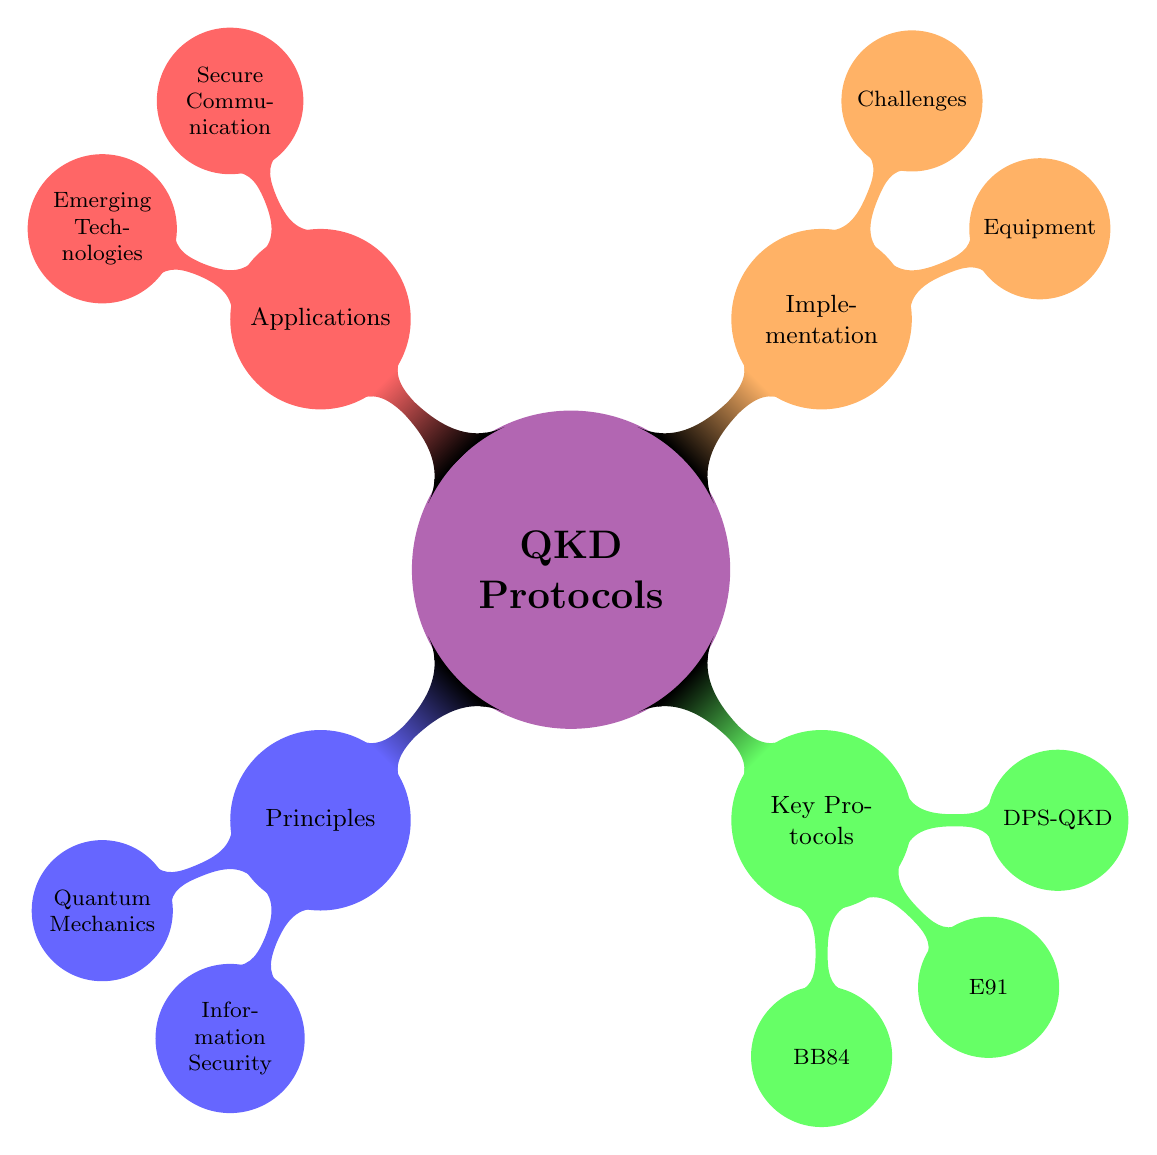What are the two main categories under Principles? The diagram shows that Principles consists of two nodes: Quantum Mechanics and Information Security. These are the primary categories under the Principles node.
Answer: Quantum Mechanics, Information Security How many key protocols are listed in the diagram? Counting the nodes under Key Protocols, there are three specific protocols mentioned: BB84, E91, and DPS-QKD. Thus, the total number is three.
Answer: 3 What technology is used for secure communication according to the Applications section? The Secure Communication category lists specific applications such as Banking Transactions, Military Communications, and Governmental Data Protection. All these fall under the secure communication technology.
Answer: Banking Transactions, Military Communications, Governmental Data Protection Which principle explains why quantum states cannot be copied? The No-cloning Theorem is part of Information Security under the Principles node, and it explains the inability to duplicate quantum states, which is a fundamental aspect of quantum information theory.
Answer: No-cloning Theorem What equipment is essential for implementing QKD protocols? Under the Implementation section, the Equipment node includes Single-Photon Detectors, Quantum Random Number Generators, and Optical Fibers as critical components for setting up QKD systems.
Answer: Single-Photon Detectors, Quantum Random Number Generators, Optical Fibers What is the main technique used by the BB84 Protocol? The BB84 Protocol employs Photon Polarization as its main technique in establishing a quantum key distribution, which is explicitly mentioned in the Key Protocols section of the diagram.
Answer: Photon Polarization How does the E91 Protocol ensure security? The E91 Protocol ensures security through the principles encapsulated in Bell Inequality and Random Basis Measurement, which are both strategies employed to verify secure key distribution.
Answer: Bell Inequality, Random Basis Measurement What is one challenge listed in implementing QKD? Photon Loss is one of the significant challenges highlighted in the Implementation section under the Challenges node, indicating difficulties in maintaining effective communication channels in QKD applications.
Answer: Photon Loss 